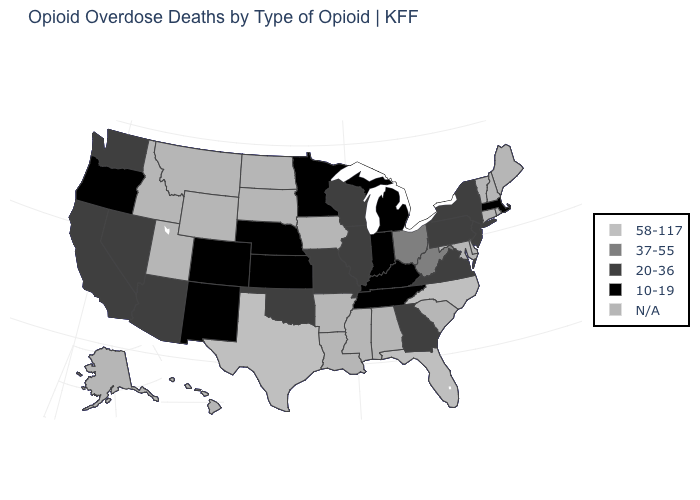Which states hav the highest value in the South?
Concise answer only. Florida, North Carolina, Texas. What is the value of Rhode Island?
Short answer required. N/A. What is the value of Ohio?
Write a very short answer. 37-55. Does New York have the lowest value in the Northeast?
Short answer required. No. Which states hav the highest value in the Northeast?
Short answer required. New Jersey, New York, Pennsylvania. What is the value of Ohio?
Write a very short answer. 37-55. Name the states that have a value in the range 37-55?
Keep it brief. Ohio, West Virginia. What is the value of New Jersey?
Keep it brief. 20-36. What is the value of Kansas?
Answer briefly. 10-19. Name the states that have a value in the range 58-117?
Short answer required. Florida, North Carolina, Texas. Does Pennsylvania have the highest value in the Northeast?
Keep it brief. Yes. How many symbols are there in the legend?
Quick response, please. 5. Which states have the highest value in the USA?
Be succinct. Florida, North Carolina, Texas. Name the states that have a value in the range 10-19?
Concise answer only. Colorado, Indiana, Kansas, Kentucky, Massachusetts, Michigan, Minnesota, Nebraska, New Mexico, Oregon, Tennessee. Does Tennessee have the highest value in the South?
Concise answer only. No. 